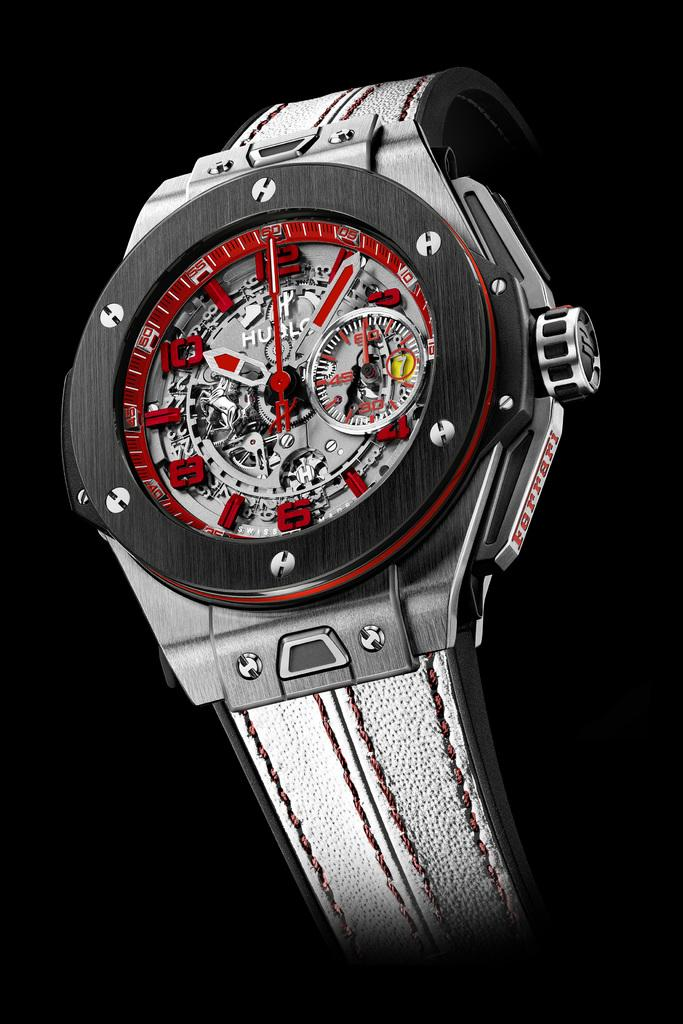What object is the main focus of the image? There is a watch in the image. What colors are used for the watch? The watch is in black and gray color. How would you describe the overall appearance of the image? The background of the image is dark. What type of cable can be seen connected to the watch in the image? There is no cable connected to the watch in the image. 